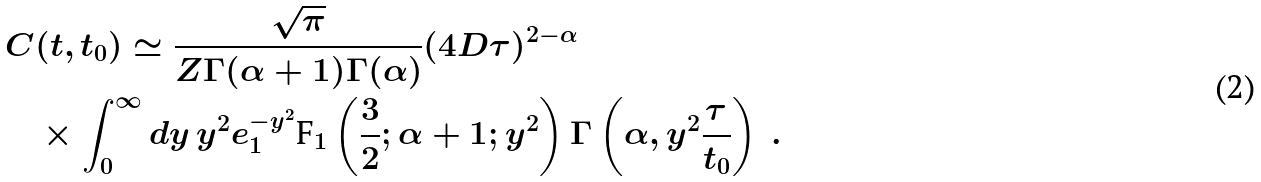<formula> <loc_0><loc_0><loc_500><loc_500>C & ( t , t _ { 0 } ) \simeq \frac { \sqrt { \pi } } { Z \Gamma ( \alpha + 1 ) \Gamma ( \alpha ) } ( 4 D \tau ) ^ { 2 - \alpha } \\ & \times \int _ { 0 } ^ { \infty } d y \, y ^ { 2 } e ^ { - y ^ { 2 } } _ { 1 } \text {F} _ { 1 } \left ( \frac { 3 } { 2 } ; \alpha + 1 ; y ^ { 2 } \right ) \Gamma \left ( \alpha , y ^ { 2 } \frac { \tau } { t _ { 0 } } \right ) \ .</formula> 